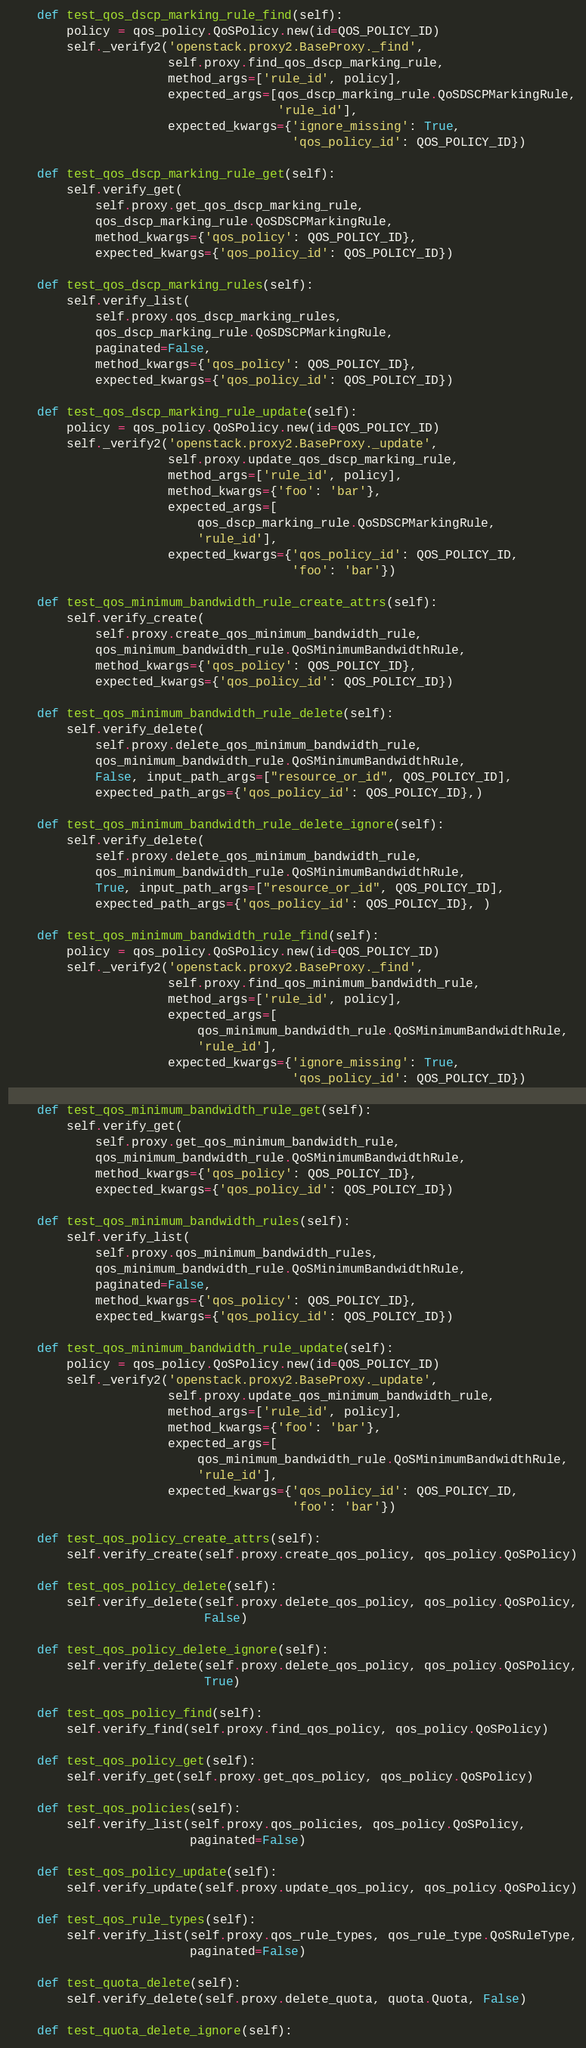Convert code to text. <code><loc_0><loc_0><loc_500><loc_500><_Python_>
    def test_qos_dscp_marking_rule_find(self):
        policy = qos_policy.QoSPolicy.new(id=QOS_POLICY_ID)
        self._verify2('openstack.proxy2.BaseProxy._find',
                      self.proxy.find_qos_dscp_marking_rule,
                      method_args=['rule_id', policy],
                      expected_args=[qos_dscp_marking_rule.QoSDSCPMarkingRule,
                                     'rule_id'],
                      expected_kwargs={'ignore_missing': True,
                                       'qos_policy_id': QOS_POLICY_ID})

    def test_qos_dscp_marking_rule_get(self):
        self.verify_get(
            self.proxy.get_qos_dscp_marking_rule,
            qos_dscp_marking_rule.QoSDSCPMarkingRule,
            method_kwargs={'qos_policy': QOS_POLICY_ID},
            expected_kwargs={'qos_policy_id': QOS_POLICY_ID})

    def test_qos_dscp_marking_rules(self):
        self.verify_list(
            self.proxy.qos_dscp_marking_rules,
            qos_dscp_marking_rule.QoSDSCPMarkingRule,
            paginated=False,
            method_kwargs={'qos_policy': QOS_POLICY_ID},
            expected_kwargs={'qos_policy_id': QOS_POLICY_ID})

    def test_qos_dscp_marking_rule_update(self):
        policy = qos_policy.QoSPolicy.new(id=QOS_POLICY_ID)
        self._verify2('openstack.proxy2.BaseProxy._update',
                      self.proxy.update_qos_dscp_marking_rule,
                      method_args=['rule_id', policy],
                      method_kwargs={'foo': 'bar'},
                      expected_args=[
                          qos_dscp_marking_rule.QoSDSCPMarkingRule,
                          'rule_id'],
                      expected_kwargs={'qos_policy_id': QOS_POLICY_ID,
                                       'foo': 'bar'})

    def test_qos_minimum_bandwidth_rule_create_attrs(self):
        self.verify_create(
            self.proxy.create_qos_minimum_bandwidth_rule,
            qos_minimum_bandwidth_rule.QoSMinimumBandwidthRule,
            method_kwargs={'qos_policy': QOS_POLICY_ID},
            expected_kwargs={'qos_policy_id': QOS_POLICY_ID})

    def test_qos_minimum_bandwidth_rule_delete(self):
        self.verify_delete(
            self.proxy.delete_qos_minimum_bandwidth_rule,
            qos_minimum_bandwidth_rule.QoSMinimumBandwidthRule,
            False, input_path_args=["resource_or_id", QOS_POLICY_ID],
            expected_path_args={'qos_policy_id': QOS_POLICY_ID},)

    def test_qos_minimum_bandwidth_rule_delete_ignore(self):
        self.verify_delete(
            self.proxy.delete_qos_minimum_bandwidth_rule,
            qos_minimum_bandwidth_rule.QoSMinimumBandwidthRule,
            True, input_path_args=["resource_or_id", QOS_POLICY_ID],
            expected_path_args={'qos_policy_id': QOS_POLICY_ID}, )

    def test_qos_minimum_bandwidth_rule_find(self):
        policy = qos_policy.QoSPolicy.new(id=QOS_POLICY_ID)
        self._verify2('openstack.proxy2.BaseProxy._find',
                      self.proxy.find_qos_minimum_bandwidth_rule,
                      method_args=['rule_id', policy],
                      expected_args=[
                          qos_minimum_bandwidth_rule.QoSMinimumBandwidthRule,
                          'rule_id'],
                      expected_kwargs={'ignore_missing': True,
                                       'qos_policy_id': QOS_POLICY_ID})

    def test_qos_minimum_bandwidth_rule_get(self):
        self.verify_get(
            self.proxy.get_qos_minimum_bandwidth_rule,
            qos_minimum_bandwidth_rule.QoSMinimumBandwidthRule,
            method_kwargs={'qos_policy': QOS_POLICY_ID},
            expected_kwargs={'qos_policy_id': QOS_POLICY_ID})

    def test_qos_minimum_bandwidth_rules(self):
        self.verify_list(
            self.proxy.qos_minimum_bandwidth_rules,
            qos_minimum_bandwidth_rule.QoSMinimumBandwidthRule,
            paginated=False,
            method_kwargs={'qos_policy': QOS_POLICY_ID},
            expected_kwargs={'qos_policy_id': QOS_POLICY_ID})

    def test_qos_minimum_bandwidth_rule_update(self):
        policy = qos_policy.QoSPolicy.new(id=QOS_POLICY_ID)
        self._verify2('openstack.proxy2.BaseProxy._update',
                      self.proxy.update_qos_minimum_bandwidth_rule,
                      method_args=['rule_id', policy],
                      method_kwargs={'foo': 'bar'},
                      expected_args=[
                          qos_minimum_bandwidth_rule.QoSMinimumBandwidthRule,
                          'rule_id'],
                      expected_kwargs={'qos_policy_id': QOS_POLICY_ID,
                                       'foo': 'bar'})

    def test_qos_policy_create_attrs(self):
        self.verify_create(self.proxy.create_qos_policy, qos_policy.QoSPolicy)

    def test_qos_policy_delete(self):
        self.verify_delete(self.proxy.delete_qos_policy, qos_policy.QoSPolicy,
                           False)

    def test_qos_policy_delete_ignore(self):
        self.verify_delete(self.proxy.delete_qos_policy, qos_policy.QoSPolicy,
                           True)

    def test_qos_policy_find(self):
        self.verify_find(self.proxy.find_qos_policy, qos_policy.QoSPolicy)

    def test_qos_policy_get(self):
        self.verify_get(self.proxy.get_qos_policy, qos_policy.QoSPolicy)

    def test_qos_policies(self):
        self.verify_list(self.proxy.qos_policies, qos_policy.QoSPolicy,
                         paginated=False)

    def test_qos_policy_update(self):
        self.verify_update(self.proxy.update_qos_policy, qos_policy.QoSPolicy)

    def test_qos_rule_types(self):
        self.verify_list(self.proxy.qos_rule_types, qos_rule_type.QoSRuleType,
                         paginated=False)

    def test_quota_delete(self):
        self.verify_delete(self.proxy.delete_quota, quota.Quota, False)

    def test_quota_delete_ignore(self):</code> 